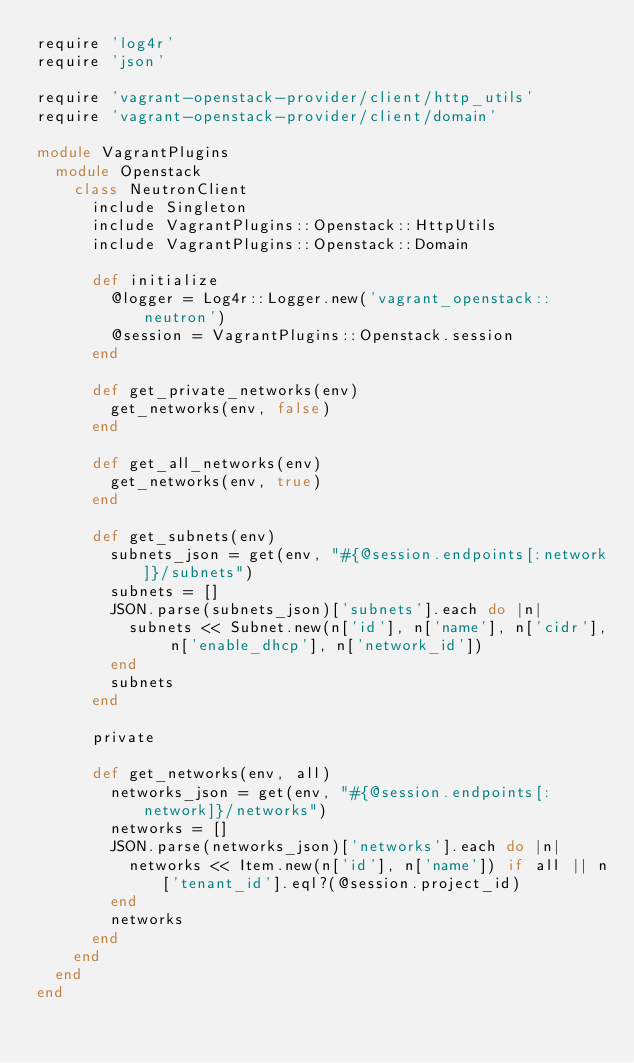<code> <loc_0><loc_0><loc_500><loc_500><_Ruby_>require 'log4r'
require 'json'

require 'vagrant-openstack-provider/client/http_utils'
require 'vagrant-openstack-provider/client/domain'

module VagrantPlugins
  module Openstack
    class NeutronClient
      include Singleton
      include VagrantPlugins::Openstack::HttpUtils
      include VagrantPlugins::Openstack::Domain

      def initialize
        @logger = Log4r::Logger.new('vagrant_openstack::neutron')
        @session = VagrantPlugins::Openstack.session
      end

      def get_private_networks(env)
        get_networks(env, false)
      end

      def get_all_networks(env)
        get_networks(env, true)
      end

      def get_subnets(env)
        subnets_json = get(env, "#{@session.endpoints[:network]}/subnets")
        subnets = []
        JSON.parse(subnets_json)['subnets'].each do |n|
          subnets << Subnet.new(n['id'], n['name'], n['cidr'], n['enable_dhcp'], n['network_id'])
        end
        subnets
      end

      private

      def get_networks(env, all)
        networks_json = get(env, "#{@session.endpoints[:network]}/networks")
        networks = []
        JSON.parse(networks_json)['networks'].each do |n|
          networks << Item.new(n['id'], n['name']) if all || n['tenant_id'].eql?(@session.project_id)
        end
        networks
      end
    end
  end
end
</code> 